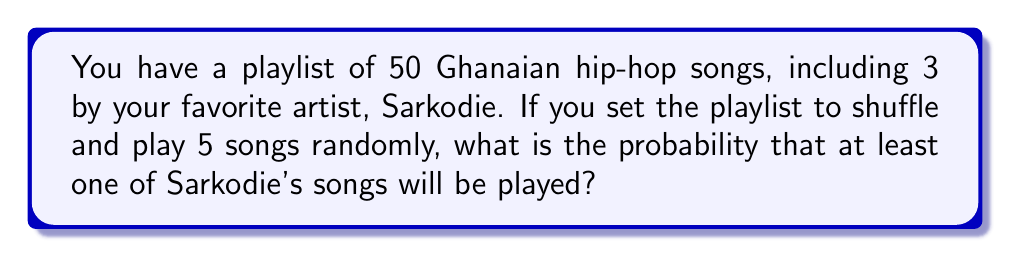Solve this math problem. Let's approach this step-by-step:

1) First, we need to calculate the probability of not hearing any of Sarkodie's songs in 5 plays. This is easier than calculating the probability of hearing at least one.

2) The probability of not selecting a Sarkodie song on a single play is:

   $$\frac{47}{50} = 0.94$$

3) For all 5 plays to not be Sarkodie songs, this needs to happen 5 times in a row. The probability of this is:

   $$\left(\frac{47}{50}\right)^5 \approx 0.7351$$

4) Therefore, the probability of hearing at least one Sarkodie song is the opposite of hearing no Sarkodie songs:

   $$1 - \left(\frac{47}{50}\right)^5 \approx 1 - 0.7351 = 0.2649$$

5) We can also express this as a percentage:

   $$0.2649 \times 100\% \approx 26.49\%$$

This means you have about a 26.49% chance of hearing at least one Sarkodie song in 5 random plays from your playlist.
Answer: The probability is approximately 0.2649 or 26.49%. 